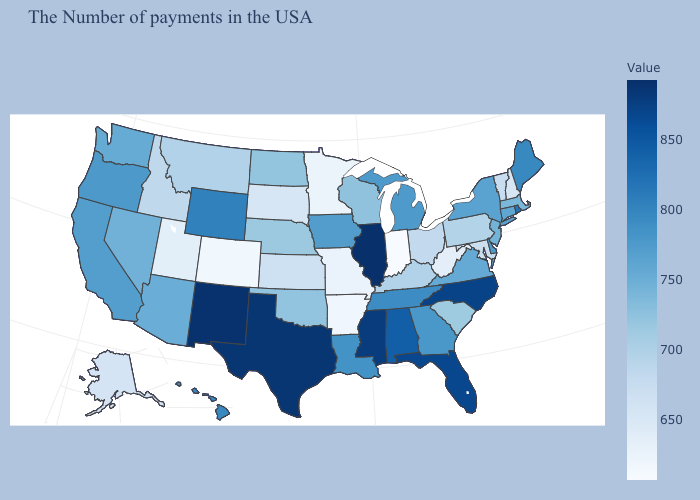Does Maryland have the lowest value in the USA?
Keep it brief. No. Among the states that border Utah , does Colorado have the lowest value?
Answer briefly. Yes. Does New Mexico have the lowest value in the USA?
Keep it brief. No. Does Wyoming have a lower value than Arizona?
Be succinct. No. Is the legend a continuous bar?
Answer briefly. Yes. Is the legend a continuous bar?
Write a very short answer. Yes. 